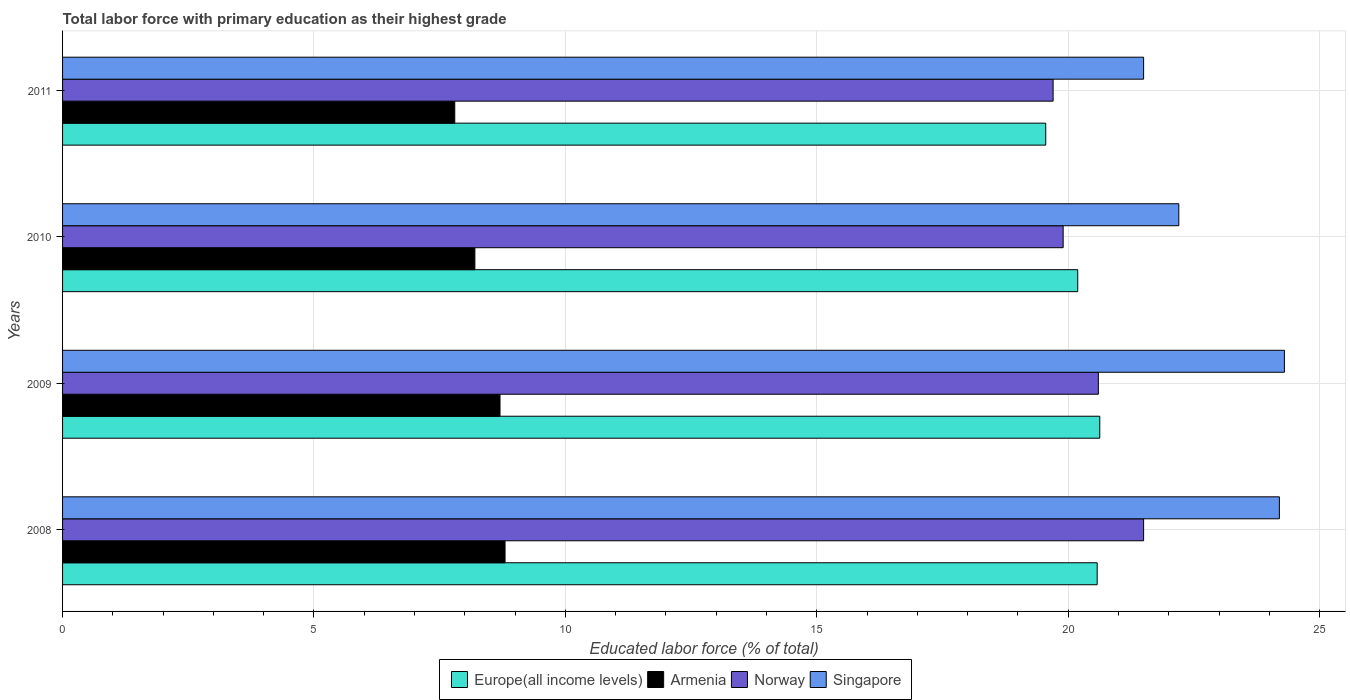How many different coloured bars are there?
Your answer should be compact. 4. Are the number of bars per tick equal to the number of legend labels?
Ensure brevity in your answer.  Yes. Are the number of bars on each tick of the Y-axis equal?
Your answer should be very brief. Yes. What is the percentage of total labor force with primary education in Armenia in 2011?
Make the answer very short. 7.8. Across all years, what is the maximum percentage of total labor force with primary education in Europe(all income levels)?
Your answer should be very brief. 20.63. Across all years, what is the minimum percentage of total labor force with primary education in Singapore?
Provide a succinct answer. 21.5. What is the total percentage of total labor force with primary education in Europe(all income levels) in the graph?
Make the answer very short. 80.95. What is the difference between the percentage of total labor force with primary education in Singapore in 2008 and that in 2011?
Give a very brief answer. 2.7. What is the difference between the percentage of total labor force with primary education in Singapore in 2009 and the percentage of total labor force with primary education in Norway in 2011?
Ensure brevity in your answer.  4.6. What is the average percentage of total labor force with primary education in Singapore per year?
Provide a succinct answer. 23.05. In the year 2011, what is the difference between the percentage of total labor force with primary education in Armenia and percentage of total labor force with primary education in Norway?
Offer a very short reply. -11.9. In how many years, is the percentage of total labor force with primary education in Armenia greater than 22 %?
Ensure brevity in your answer.  0. What is the ratio of the percentage of total labor force with primary education in Singapore in 2009 to that in 2010?
Ensure brevity in your answer.  1.09. Is the percentage of total labor force with primary education in Singapore in 2008 less than that in 2010?
Give a very brief answer. No. What is the difference between the highest and the second highest percentage of total labor force with primary education in Norway?
Give a very brief answer. 0.9. What is the difference between the highest and the lowest percentage of total labor force with primary education in Singapore?
Offer a terse response. 2.8. In how many years, is the percentage of total labor force with primary education in Singapore greater than the average percentage of total labor force with primary education in Singapore taken over all years?
Offer a very short reply. 2. Is the sum of the percentage of total labor force with primary education in Singapore in 2008 and 2009 greater than the maximum percentage of total labor force with primary education in Armenia across all years?
Keep it short and to the point. Yes. What does the 4th bar from the top in 2009 represents?
Offer a terse response. Europe(all income levels). What does the 2nd bar from the bottom in 2009 represents?
Give a very brief answer. Armenia. Is it the case that in every year, the sum of the percentage of total labor force with primary education in Norway and percentage of total labor force with primary education in Armenia is greater than the percentage of total labor force with primary education in Europe(all income levels)?
Give a very brief answer. Yes. Are all the bars in the graph horizontal?
Ensure brevity in your answer.  Yes. Are the values on the major ticks of X-axis written in scientific E-notation?
Ensure brevity in your answer.  No. Does the graph contain any zero values?
Make the answer very short. No. Does the graph contain grids?
Provide a short and direct response. Yes. How are the legend labels stacked?
Your answer should be compact. Horizontal. What is the title of the graph?
Give a very brief answer. Total labor force with primary education as their highest grade. Does "Togo" appear as one of the legend labels in the graph?
Make the answer very short. No. What is the label or title of the X-axis?
Offer a very short reply. Educated labor force (% of total). What is the label or title of the Y-axis?
Provide a succinct answer. Years. What is the Educated labor force (% of total) in Europe(all income levels) in 2008?
Ensure brevity in your answer.  20.58. What is the Educated labor force (% of total) in Armenia in 2008?
Your response must be concise. 8.8. What is the Educated labor force (% of total) of Norway in 2008?
Provide a short and direct response. 21.5. What is the Educated labor force (% of total) of Singapore in 2008?
Offer a very short reply. 24.2. What is the Educated labor force (% of total) in Europe(all income levels) in 2009?
Keep it short and to the point. 20.63. What is the Educated labor force (% of total) of Armenia in 2009?
Your answer should be compact. 8.7. What is the Educated labor force (% of total) of Norway in 2009?
Provide a short and direct response. 20.6. What is the Educated labor force (% of total) in Singapore in 2009?
Offer a very short reply. 24.3. What is the Educated labor force (% of total) in Europe(all income levels) in 2010?
Your answer should be very brief. 20.19. What is the Educated labor force (% of total) in Armenia in 2010?
Your response must be concise. 8.2. What is the Educated labor force (% of total) in Norway in 2010?
Provide a succinct answer. 19.9. What is the Educated labor force (% of total) in Singapore in 2010?
Ensure brevity in your answer.  22.2. What is the Educated labor force (% of total) in Europe(all income levels) in 2011?
Provide a short and direct response. 19.55. What is the Educated labor force (% of total) in Armenia in 2011?
Offer a very short reply. 7.8. What is the Educated labor force (% of total) in Norway in 2011?
Your answer should be very brief. 19.7. Across all years, what is the maximum Educated labor force (% of total) in Europe(all income levels)?
Offer a very short reply. 20.63. Across all years, what is the maximum Educated labor force (% of total) of Armenia?
Your answer should be compact. 8.8. Across all years, what is the maximum Educated labor force (% of total) of Singapore?
Your answer should be compact. 24.3. Across all years, what is the minimum Educated labor force (% of total) in Europe(all income levels)?
Provide a succinct answer. 19.55. Across all years, what is the minimum Educated labor force (% of total) of Armenia?
Ensure brevity in your answer.  7.8. Across all years, what is the minimum Educated labor force (% of total) of Norway?
Keep it short and to the point. 19.7. Across all years, what is the minimum Educated labor force (% of total) of Singapore?
Your answer should be very brief. 21.5. What is the total Educated labor force (% of total) in Europe(all income levels) in the graph?
Offer a terse response. 80.95. What is the total Educated labor force (% of total) in Armenia in the graph?
Give a very brief answer. 33.5. What is the total Educated labor force (% of total) in Norway in the graph?
Keep it short and to the point. 81.7. What is the total Educated labor force (% of total) of Singapore in the graph?
Provide a short and direct response. 92.2. What is the difference between the Educated labor force (% of total) in Europe(all income levels) in 2008 and that in 2009?
Keep it short and to the point. -0.05. What is the difference between the Educated labor force (% of total) of Armenia in 2008 and that in 2009?
Your answer should be very brief. 0.1. What is the difference between the Educated labor force (% of total) of Europe(all income levels) in 2008 and that in 2010?
Your answer should be very brief. 0.39. What is the difference between the Educated labor force (% of total) in Armenia in 2008 and that in 2010?
Make the answer very short. 0.6. What is the difference between the Educated labor force (% of total) of Singapore in 2008 and that in 2010?
Provide a short and direct response. 2. What is the difference between the Educated labor force (% of total) in Europe(all income levels) in 2008 and that in 2011?
Make the answer very short. 1.02. What is the difference between the Educated labor force (% of total) of Armenia in 2008 and that in 2011?
Your response must be concise. 1. What is the difference between the Educated labor force (% of total) in Norway in 2008 and that in 2011?
Give a very brief answer. 1.8. What is the difference between the Educated labor force (% of total) of Singapore in 2008 and that in 2011?
Offer a very short reply. 2.7. What is the difference between the Educated labor force (% of total) of Europe(all income levels) in 2009 and that in 2010?
Ensure brevity in your answer.  0.44. What is the difference between the Educated labor force (% of total) of Armenia in 2009 and that in 2010?
Ensure brevity in your answer.  0.5. What is the difference between the Educated labor force (% of total) in Singapore in 2009 and that in 2010?
Your answer should be very brief. 2.1. What is the difference between the Educated labor force (% of total) of Europe(all income levels) in 2009 and that in 2011?
Provide a short and direct response. 1.07. What is the difference between the Educated labor force (% of total) of Armenia in 2009 and that in 2011?
Keep it short and to the point. 0.9. What is the difference between the Educated labor force (% of total) in Singapore in 2009 and that in 2011?
Ensure brevity in your answer.  2.8. What is the difference between the Educated labor force (% of total) of Europe(all income levels) in 2010 and that in 2011?
Offer a terse response. 0.64. What is the difference between the Educated labor force (% of total) of Armenia in 2010 and that in 2011?
Provide a short and direct response. 0.4. What is the difference between the Educated labor force (% of total) in Norway in 2010 and that in 2011?
Offer a terse response. 0.2. What is the difference between the Educated labor force (% of total) of Singapore in 2010 and that in 2011?
Your answer should be very brief. 0.7. What is the difference between the Educated labor force (% of total) of Europe(all income levels) in 2008 and the Educated labor force (% of total) of Armenia in 2009?
Make the answer very short. 11.88. What is the difference between the Educated labor force (% of total) in Europe(all income levels) in 2008 and the Educated labor force (% of total) in Norway in 2009?
Your response must be concise. -0.02. What is the difference between the Educated labor force (% of total) of Europe(all income levels) in 2008 and the Educated labor force (% of total) of Singapore in 2009?
Your response must be concise. -3.72. What is the difference between the Educated labor force (% of total) of Armenia in 2008 and the Educated labor force (% of total) of Singapore in 2009?
Ensure brevity in your answer.  -15.5. What is the difference between the Educated labor force (% of total) of Norway in 2008 and the Educated labor force (% of total) of Singapore in 2009?
Your answer should be compact. -2.8. What is the difference between the Educated labor force (% of total) in Europe(all income levels) in 2008 and the Educated labor force (% of total) in Armenia in 2010?
Give a very brief answer. 12.38. What is the difference between the Educated labor force (% of total) of Europe(all income levels) in 2008 and the Educated labor force (% of total) of Norway in 2010?
Keep it short and to the point. 0.68. What is the difference between the Educated labor force (% of total) in Europe(all income levels) in 2008 and the Educated labor force (% of total) in Singapore in 2010?
Your answer should be compact. -1.62. What is the difference between the Educated labor force (% of total) of Armenia in 2008 and the Educated labor force (% of total) of Norway in 2010?
Provide a succinct answer. -11.1. What is the difference between the Educated labor force (% of total) of Europe(all income levels) in 2008 and the Educated labor force (% of total) of Armenia in 2011?
Provide a short and direct response. 12.78. What is the difference between the Educated labor force (% of total) in Europe(all income levels) in 2008 and the Educated labor force (% of total) in Norway in 2011?
Make the answer very short. 0.88. What is the difference between the Educated labor force (% of total) of Europe(all income levels) in 2008 and the Educated labor force (% of total) of Singapore in 2011?
Make the answer very short. -0.92. What is the difference between the Educated labor force (% of total) of Europe(all income levels) in 2009 and the Educated labor force (% of total) of Armenia in 2010?
Give a very brief answer. 12.43. What is the difference between the Educated labor force (% of total) of Europe(all income levels) in 2009 and the Educated labor force (% of total) of Norway in 2010?
Provide a succinct answer. 0.73. What is the difference between the Educated labor force (% of total) of Europe(all income levels) in 2009 and the Educated labor force (% of total) of Singapore in 2010?
Your answer should be compact. -1.57. What is the difference between the Educated labor force (% of total) in Norway in 2009 and the Educated labor force (% of total) in Singapore in 2010?
Ensure brevity in your answer.  -1.6. What is the difference between the Educated labor force (% of total) in Europe(all income levels) in 2009 and the Educated labor force (% of total) in Armenia in 2011?
Your response must be concise. 12.83. What is the difference between the Educated labor force (% of total) of Europe(all income levels) in 2009 and the Educated labor force (% of total) of Norway in 2011?
Your response must be concise. 0.93. What is the difference between the Educated labor force (% of total) of Europe(all income levels) in 2009 and the Educated labor force (% of total) of Singapore in 2011?
Provide a short and direct response. -0.87. What is the difference between the Educated labor force (% of total) of Armenia in 2009 and the Educated labor force (% of total) of Norway in 2011?
Keep it short and to the point. -11. What is the difference between the Educated labor force (% of total) in Europe(all income levels) in 2010 and the Educated labor force (% of total) in Armenia in 2011?
Give a very brief answer. 12.39. What is the difference between the Educated labor force (% of total) of Europe(all income levels) in 2010 and the Educated labor force (% of total) of Norway in 2011?
Your answer should be very brief. 0.49. What is the difference between the Educated labor force (% of total) of Europe(all income levels) in 2010 and the Educated labor force (% of total) of Singapore in 2011?
Give a very brief answer. -1.31. What is the difference between the Educated labor force (% of total) in Armenia in 2010 and the Educated labor force (% of total) in Norway in 2011?
Give a very brief answer. -11.5. What is the average Educated labor force (% of total) in Europe(all income levels) per year?
Your answer should be compact. 20.24. What is the average Educated labor force (% of total) in Armenia per year?
Your answer should be very brief. 8.38. What is the average Educated labor force (% of total) in Norway per year?
Your answer should be compact. 20.43. What is the average Educated labor force (% of total) of Singapore per year?
Offer a terse response. 23.05. In the year 2008, what is the difference between the Educated labor force (% of total) of Europe(all income levels) and Educated labor force (% of total) of Armenia?
Ensure brevity in your answer.  11.78. In the year 2008, what is the difference between the Educated labor force (% of total) of Europe(all income levels) and Educated labor force (% of total) of Norway?
Provide a short and direct response. -0.92. In the year 2008, what is the difference between the Educated labor force (% of total) of Europe(all income levels) and Educated labor force (% of total) of Singapore?
Ensure brevity in your answer.  -3.62. In the year 2008, what is the difference between the Educated labor force (% of total) in Armenia and Educated labor force (% of total) in Singapore?
Provide a short and direct response. -15.4. In the year 2008, what is the difference between the Educated labor force (% of total) of Norway and Educated labor force (% of total) of Singapore?
Your answer should be very brief. -2.7. In the year 2009, what is the difference between the Educated labor force (% of total) of Europe(all income levels) and Educated labor force (% of total) of Armenia?
Your answer should be very brief. 11.93. In the year 2009, what is the difference between the Educated labor force (% of total) in Europe(all income levels) and Educated labor force (% of total) in Norway?
Your answer should be compact. 0.03. In the year 2009, what is the difference between the Educated labor force (% of total) in Europe(all income levels) and Educated labor force (% of total) in Singapore?
Your answer should be very brief. -3.67. In the year 2009, what is the difference between the Educated labor force (% of total) of Armenia and Educated labor force (% of total) of Singapore?
Provide a short and direct response. -15.6. In the year 2010, what is the difference between the Educated labor force (% of total) of Europe(all income levels) and Educated labor force (% of total) of Armenia?
Provide a short and direct response. 11.99. In the year 2010, what is the difference between the Educated labor force (% of total) in Europe(all income levels) and Educated labor force (% of total) in Norway?
Give a very brief answer. 0.29. In the year 2010, what is the difference between the Educated labor force (% of total) in Europe(all income levels) and Educated labor force (% of total) in Singapore?
Your answer should be very brief. -2.01. In the year 2010, what is the difference between the Educated labor force (% of total) in Armenia and Educated labor force (% of total) in Singapore?
Your answer should be very brief. -14. In the year 2010, what is the difference between the Educated labor force (% of total) of Norway and Educated labor force (% of total) of Singapore?
Offer a very short reply. -2.3. In the year 2011, what is the difference between the Educated labor force (% of total) of Europe(all income levels) and Educated labor force (% of total) of Armenia?
Ensure brevity in your answer.  11.75. In the year 2011, what is the difference between the Educated labor force (% of total) in Europe(all income levels) and Educated labor force (% of total) in Norway?
Your response must be concise. -0.15. In the year 2011, what is the difference between the Educated labor force (% of total) of Europe(all income levels) and Educated labor force (% of total) of Singapore?
Offer a very short reply. -1.95. In the year 2011, what is the difference between the Educated labor force (% of total) of Armenia and Educated labor force (% of total) of Singapore?
Your answer should be compact. -13.7. What is the ratio of the Educated labor force (% of total) of Armenia in 2008 to that in 2009?
Offer a very short reply. 1.01. What is the ratio of the Educated labor force (% of total) in Norway in 2008 to that in 2009?
Ensure brevity in your answer.  1.04. What is the ratio of the Educated labor force (% of total) of Europe(all income levels) in 2008 to that in 2010?
Keep it short and to the point. 1.02. What is the ratio of the Educated labor force (% of total) of Armenia in 2008 to that in 2010?
Provide a succinct answer. 1.07. What is the ratio of the Educated labor force (% of total) of Norway in 2008 to that in 2010?
Make the answer very short. 1.08. What is the ratio of the Educated labor force (% of total) in Singapore in 2008 to that in 2010?
Your response must be concise. 1.09. What is the ratio of the Educated labor force (% of total) in Europe(all income levels) in 2008 to that in 2011?
Provide a succinct answer. 1.05. What is the ratio of the Educated labor force (% of total) in Armenia in 2008 to that in 2011?
Offer a very short reply. 1.13. What is the ratio of the Educated labor force (% of total) in Norway in 2008 to that in 2011?
Give a very brief answer. 1.09. What is the ratio of the Educated labor force (% of total) of Singapore in 2008 to that in 2011?
Your answer should be compact. 1.13. What is the ratio of the Educated labor force (% of total) of Europe(all income levels) in 2009 to that in 2010?
Give a very brief answer. 1.02. What is the ratio of the Educated labor force (% of total) of Armenia in 2009 to that in 2010?
Your answer should be compact. 1.06. What is the ratio of the Educated labor force (% of total) of Norway in 2009 to that in 2010?
Provide a short and direct response. 1.04. What is the ratio of the Educated labor force (% of total) of Singapore in 2009 to that in 2010?
Ensure brevity in your answer.  1.09. What is the ratio of the Educated labor force (% of total) of Europe(all income levels) in 2009 to that in 2011?
Your answer should be compact. 1.05. What is the ratio of the Educated labor force (% of total) in Armenia in 2009 to that in 2011?
Ensure brevity in your answer.  1.12. What is the ratio of the Educated labor force (% of total) in Norway in 2009 to that in 2011?
Offer a very short reply. 1.05. What is the ratio of the Educated labor force (% of total) of Singapore in 2009 to that in 2011?
Offer a terse response. 1.13. What is the ratio of the Educated labor force (% of total) of Europe(all income levels) in 2010 to that in 2011?
Keep it short and to the point. 1.03. What is the ratio of the Educated labor force (% of total) in Armenia in 2010 to that in 2011?
Offer a terse response. 1.05. What is the ratio of the Educated labor force (% of total) in Norway in 2010 to that in 2011?
Your answer should be compact. 1.01. What is the ratio of the Educated labor force (% of total) of Singapore in 2010 to that in 2011?
Your answer should be very brief. 1.03. What is the difference between the highest and the second highest Educated labor force (% of total) of Europe(all income levels)?
Ensure brevity in your answer.  0.05. What is the difference between the highest and the lowest Educated labor force (% of total) of Europe(all income levels)?
Offer a terse response. 1.07. What is the difference between the highest and the lowest Educated labor force (% of total) of Singapore?
Your answer should be very brief. 2.8. 